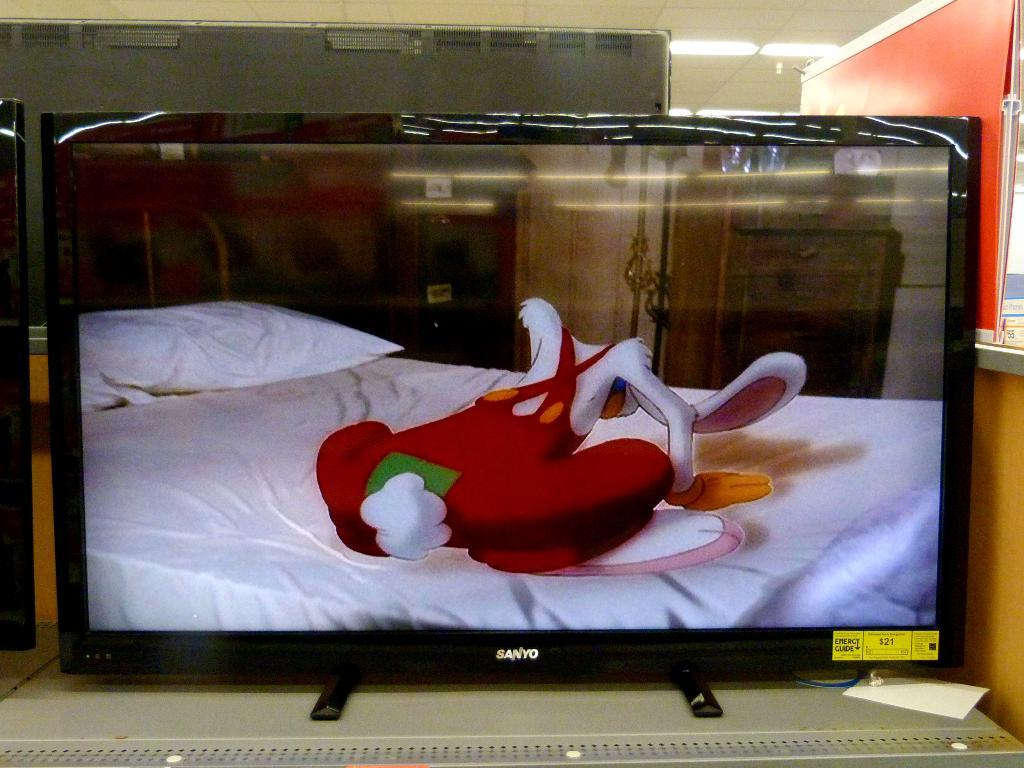What is the main object in the image? There is a monitor in the image. What is displayed on the monitor? The monitor displays a cartoon image. What can be seen in the background of the image? There are lights attached to the roof and other objects visible in the background. What type of bead is used to decorate the wilderness in the image? There is no wilderness or bead present in the image. What type of voyage is depicted in the image? There is no voyage depicted in the image; it features a monitor displaying a cartoon image. 